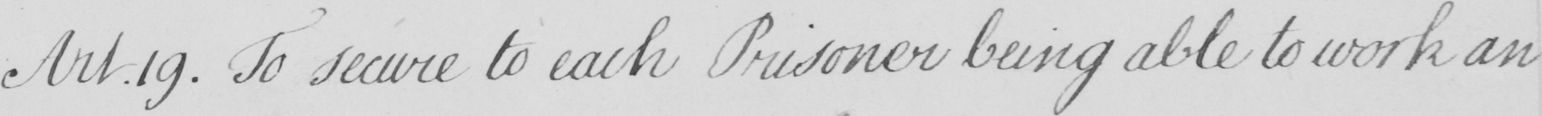What does this handwritten line say? To secure to each Prisoner being able to work an 